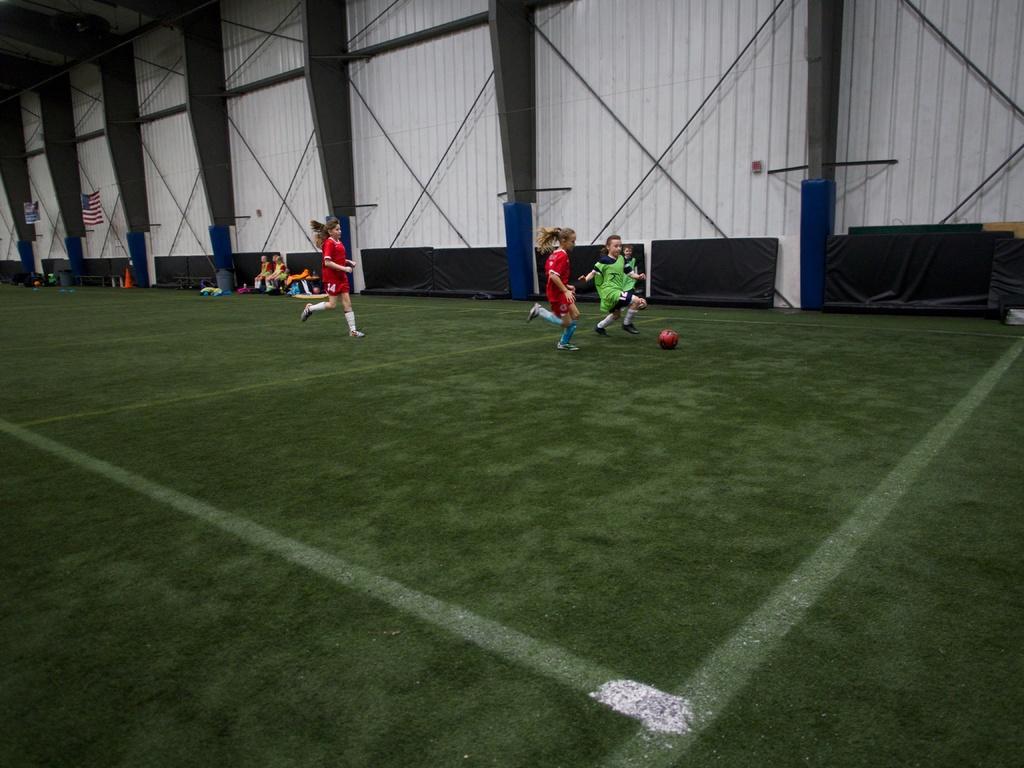In one or two sentences, can you explain what this image depicts? In this picture there is a football ground. In the center the picture there are people playing football. In the background there are people sitting on benches. Towards left, in the background there is a flag and a banner. At the top there are iron pillars and wall. 